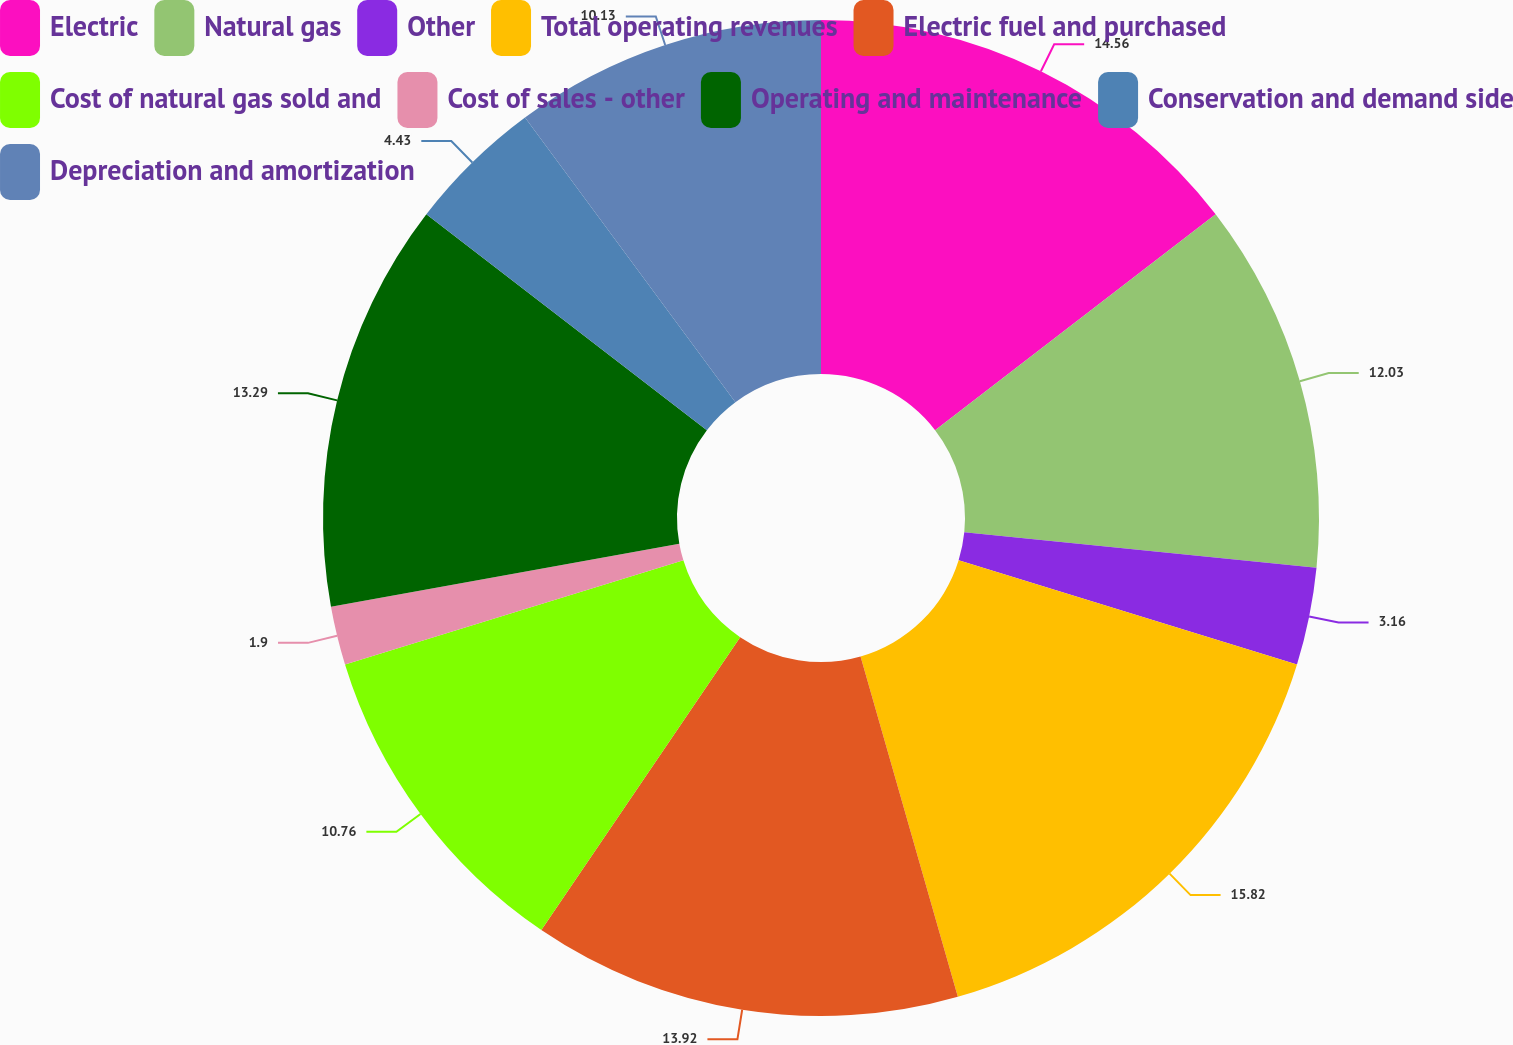Convert chart to OTSL. <chart><loc_0><loc_0><loc_500><loc_500><pie_chart><fcel>Electric<fcel>Natural gas<fcel>Other<fcel>Total operating revenues<fcel>Electric fuel and purchased<fcel>Cost of natural gas sold and<fcel>Cost of sales - other<fcel>Operating and maintenance<fcel>Conservation and demand side<fcel>Depreciation and amortization<nl><fcel>14.56%<fcel>12.03%<fcel>3.16%<fcel>15.82%<fcel>13.92%<fcel>10.76%<fcel>1.9%<fcel>13.29%<fcel>4.43%<fcel>10.13%<nl></chart> 